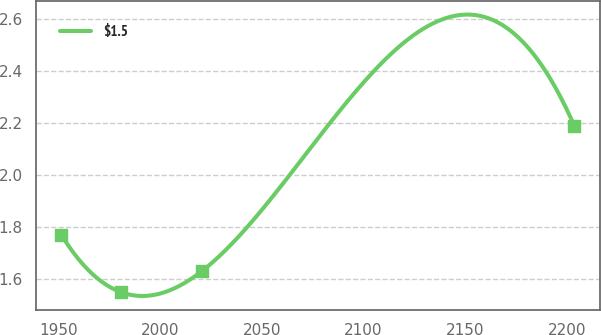<chart> <loc_0><loc_0><loc_500><loc_500><line_chart><ecel><fcel>$1.5<nl><fcel>1951.46<fcel>1.77<nl><fcel>1980.71<fcel>1.55<nl><fcel>2020.34<fcel>1.63<nl><fcel>2203.63<fcel>2.19<nl></chart> 